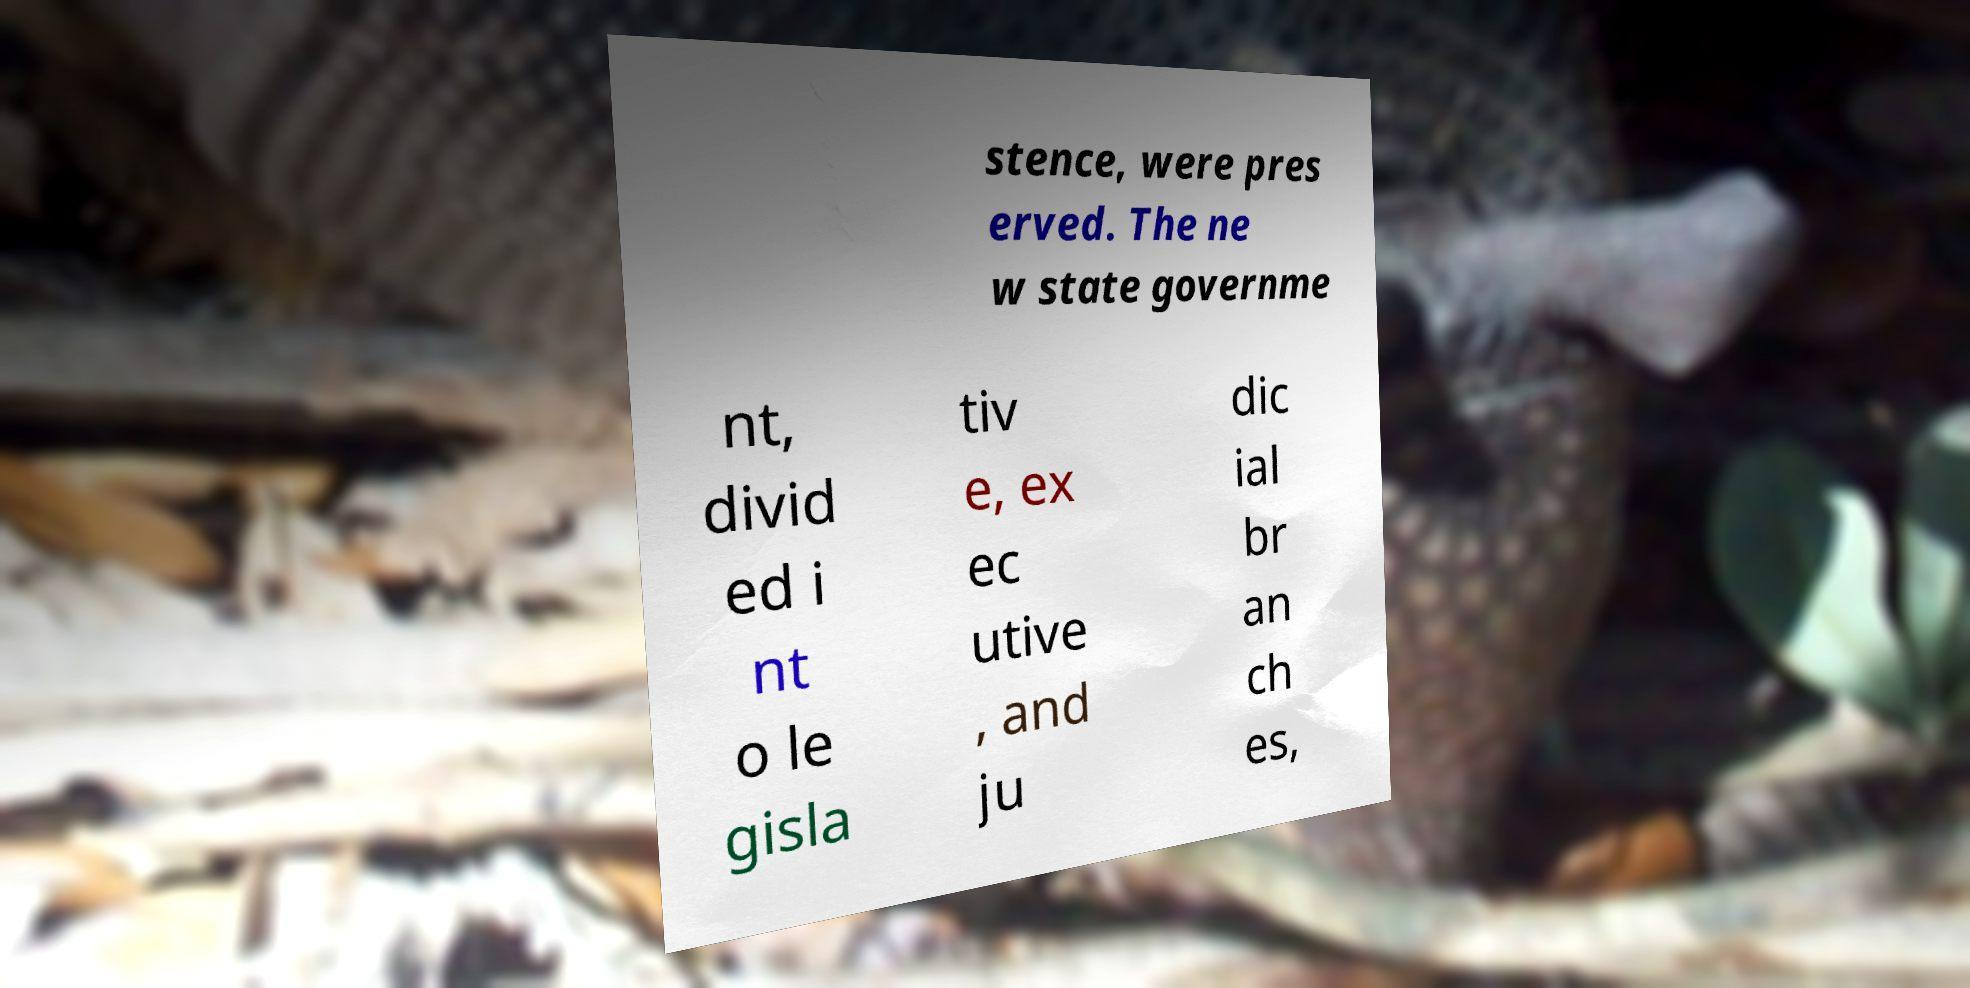I need the written content from this picture converted into text. Can you do that? stence, were pres erved. The ne w state governme nt, divid ed i nt o le gisla tiv e, ex ec utive , and ju dic ial br an ch es, 